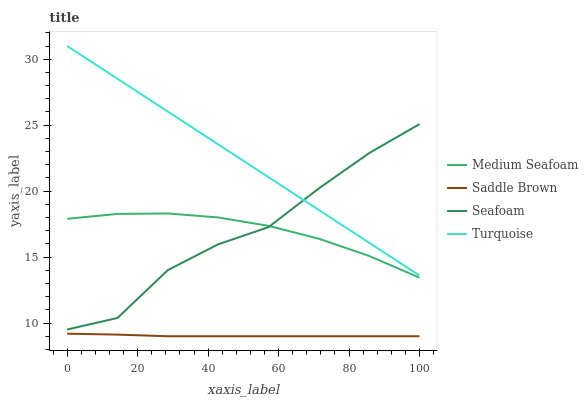Does Saddle Brown have the minimum area under the curve?
Answer yes or no. Yes. Does Turquoise have the maximum area under the curve?
Answer yes or no. Yes. Does Seafoam have the minimum area under the curve?
Answer yes or no. No. Does Seafoam have the maximum area under the curve?
Answer yes or no. No. Is Turquoise the smoothest?
Answer yes or no. Yes. Is Seafoam the roughest?
Answer yes or no. Yes. Is Medium Seafoam the smoothest?
Answer yes or no. No. Is Medium Seafoam the roughest?
Answer yes or no. No. Does Saddle Brown have the lowest value?
Answer yes or no. Yes. Does Seafoam have the lowest value?
Answer yes or no. No. Does Turquoise have the highest value?
Answer yes or no. Yes. Does Seafoam have the highest value?
Answer yes or no. No. Is Saddle Brown less than Turquoise?
Answer yes or no. Yes. Is Medium Seafoam greater than Saddle Brown?
Answer yes or no. Yes. Does Seafoam intersect Medium Seafoam?
Answer yes or no. Yes. Is Seafoam less than Medium Seafoam?
Answer yes or no. No. Is Seafoam greater than Medium Seafoam?
Answer yes or no. No. Does Saddle Brown intersect Turquoise?
Answer yes or no. No. 